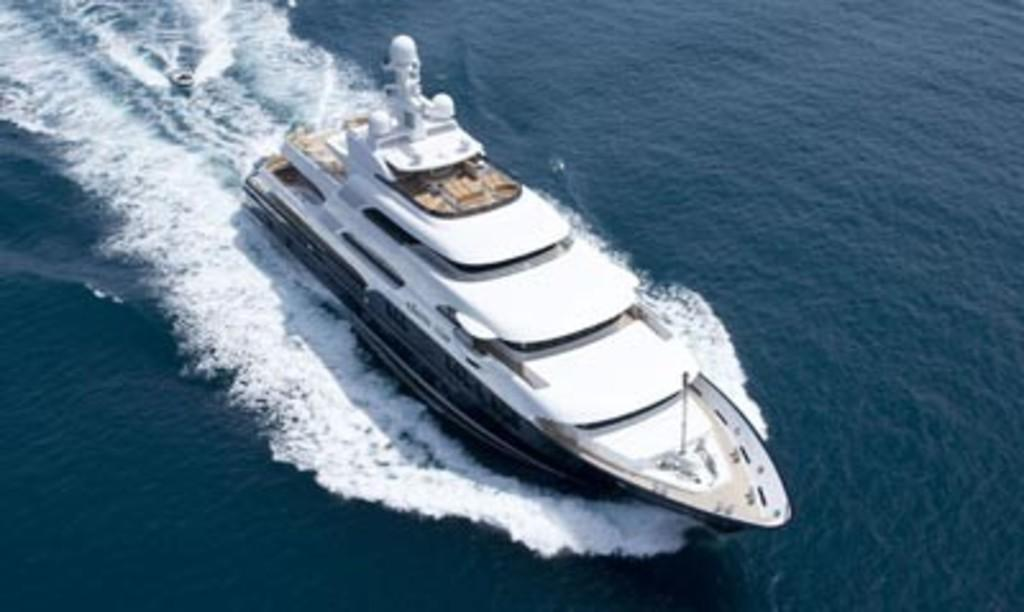What is the main subject in the center of the image? There is a boat in the center of the image. What body of water is visible at the bottom of the image? There is a river at the bottom of the image. What type of gun is being used by the person standing near the boat? There is no person or gun visible in the image; it only features a boat and a river. 